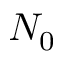Convert formula to latex. <formula><loc_0><loc_0><loc_500><loc_500>N _ { 0 }</formula> 